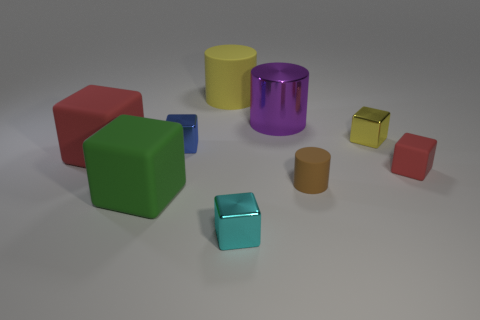Subtract all red cubes. How many cubes are left? 4 Subtract all yellow shiny cubes. How many cubes are left? 5 Subtract all purple cubes. Subtract all yellow balls. How many cubes are left? 6 Add 1 rubber cylinders. How many objects exist? 10 Subtract all cubes. How many objects are left? 3 Subtract 0 brown cubes. How many objects are left? 9 Subtract all tiny matte things. Subtract all small yellow matte cylinders. How many objects are left? 7 Add 2 big green rubber objects. How many big green rubber objects are left? 3 Add 9 tiny purple metal blocks. How many tiny purple metal blocks exist? 9 